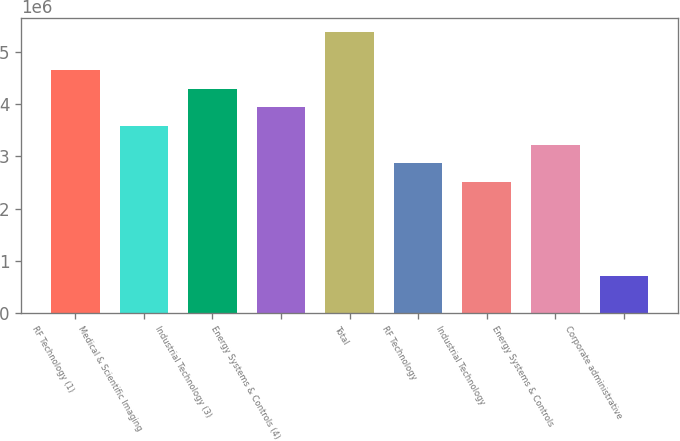Convert chart. <chart><loc_0><loc_0><loc_500><loc_500><bar_chart><fcel>RF Technology (1)<fcel>Medical & Scientific Imaging<fcel>Industrial Technology (3)<fcel>Energy Systems & Controls (4)<fcel>Total<fcel>RF Technology<fcel>Industrial Technology<fcel>Energy Systems & Controls<fcel>Corporate administrative<nl><fcel>4.65711e+06<fcel>3.5824e+06<fcel>4.29887e+06<fcel>3.94063e+06<fcel>5.37359e+06<fcel>2.86592e+06<fcel>2.50768e+06<fcel>3.22416e+06<fcel>716480<nl></chart> 